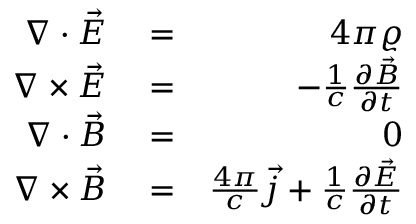Convert formula to latex. <formula><loc_0><loc_0><loc_500><loc_500>\begin{array} { r l r } { \nabla \cdot \vec { E } } & = } & { 4 \pi \varrho } \\ { \nabla \times \vec { E } } & = } & { - \frac { 1 } { c } \frac { \partial \vec { B } } { \partial t } } \\ { \nabla \cdot \vec { B } } & = } & { 0 } \\ { \nabla \times \vec { B } } & = } & { \frac { 4 \pi } { c } \vec { j } + \frac { 1 } { c } \frac { \partial \vec { E } } { \partial t } } \end{array}</formula> 